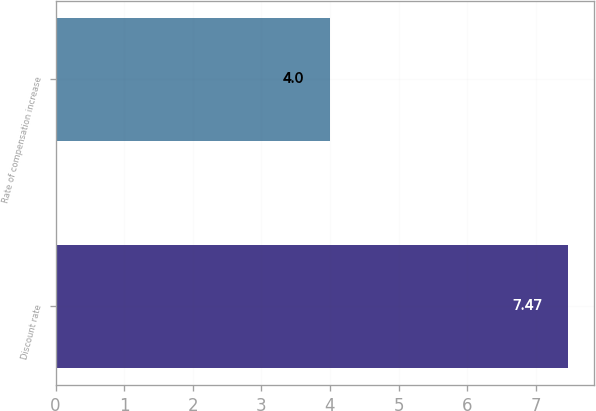Convert chart to OTSL. <chart><loc_0><loc_0><loc_500><loc_500><bar_chart><fcel>Discount rate<fcel>Rate of compensation increase<nl><fcel>7.47<fcel>4<nl></chart> 